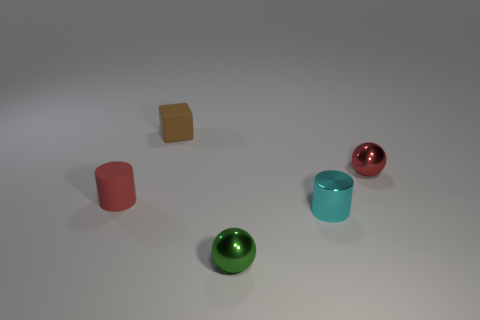There is a ball that is the same color as the tiny matte cylinder; what is it made of?
Give a very brief answer. Metal. There is a small sphere that is left of the red sphere that is in front of the brown rubber thing; what is its color?
Offer a terse response. Green. Does the red metallic thing have the same size as the matte block?
Offer a terse response. Yes. There is a red object that is the same shape as the small green metal thing; what is its material?
Give a very brief answer. Metal. What number of matte cylinders are the same size as the rubber cube?
Your answer should be compact. 1. What is the color of the other tiny ball that is the same material as the red ball?
Offer a very short reply. Green. Are there fewer red cylinders than large yellow rubber objects?
Make the answer very short. No. What number of green things are big matte cubes or small shiny cylinders?
Your response must be concise. 0. How many tiny things are both in front of the tiny cube and left of the small green sphere?
Offer a terse response. 1. Is the material of the small block the same as the red cylinder?
Your answer should be compact. Yes. 